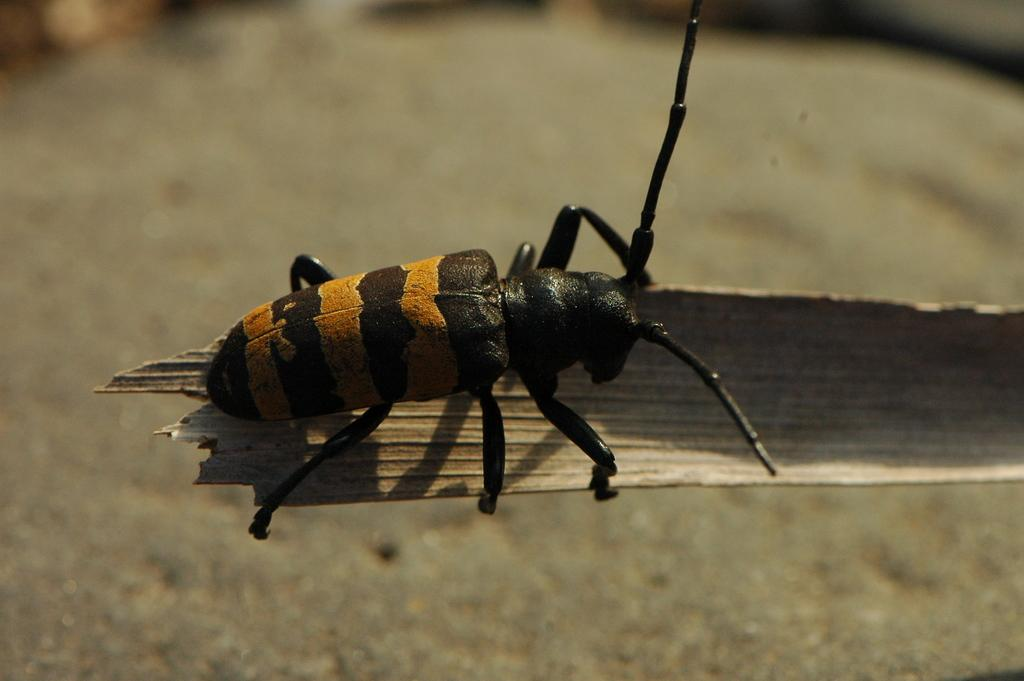What type of creature can be seen in the image? There is an insect in the image. Where is the insect located? The insect is on a wooden object. Can you describe the position of the wooden object in the image? The wooden object is in the foreground. What is visible at the bottom of the image? The bottom of the image appears to be ground. What type of stamp is visible on the insect's back in the image? There is no stamp visible on the insect's back in the image. Is there a locket hanging from the insect's neck in the image? There is no locket present in the image. 